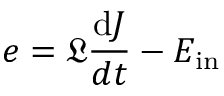<formula> <loc_0><loc_0><loc_500><loc_500>e = \mathfrak { L } \frac { d J } { d t } - E _ { i n }</formula> 